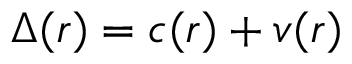Convert formula to latex. <formula><loc_0><loc_0><loc_500><loc_500>\Delta ( r ) = c ( r ) + v ( r )</formula> 